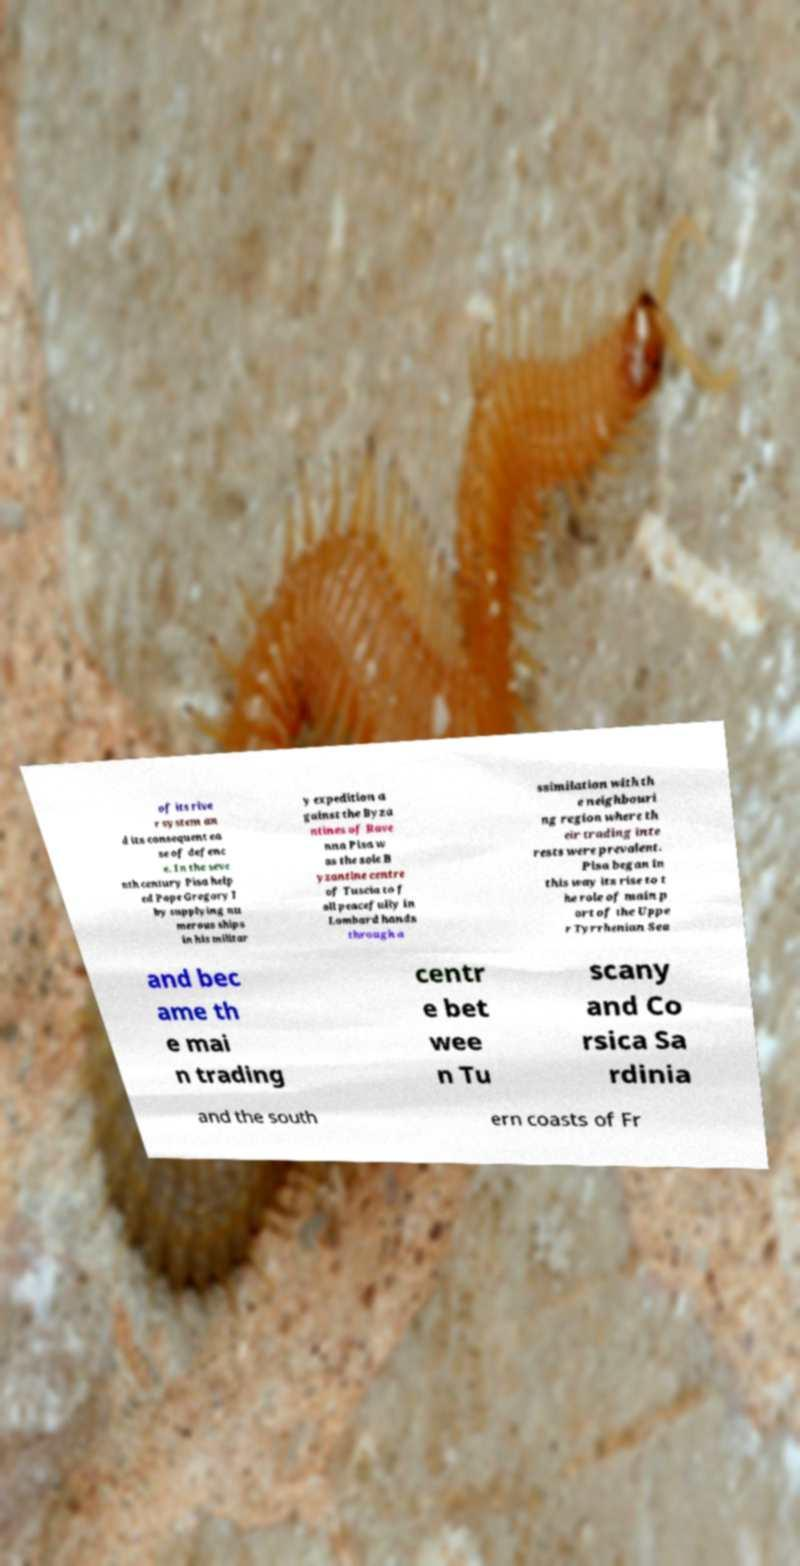There's text embedded in this image that I need extracted. Can you transcribe it verbatim? of its rive r system an d its consequent ea se of defenc e. In the seve nth century Pisa help ed Pope Gregory I by supplying nu merous ships in his militar y expedition a gainst the Byza ntines of Rave nna Pisa w as the sole B yzantine centre of Tuscia to f all peacefully in Lombard hands through a ssimilation with th e neighbouri ng region where th eir trading inte rests were prevalent. Pisa began in this way its rise to t he role of main p ort of the Uppe r Tyrrhenian Sea and bec ame th e mai n trading centr e bet wee n Tu scany and Co rsica Sa rdinia and the south ern coasts of Fr 